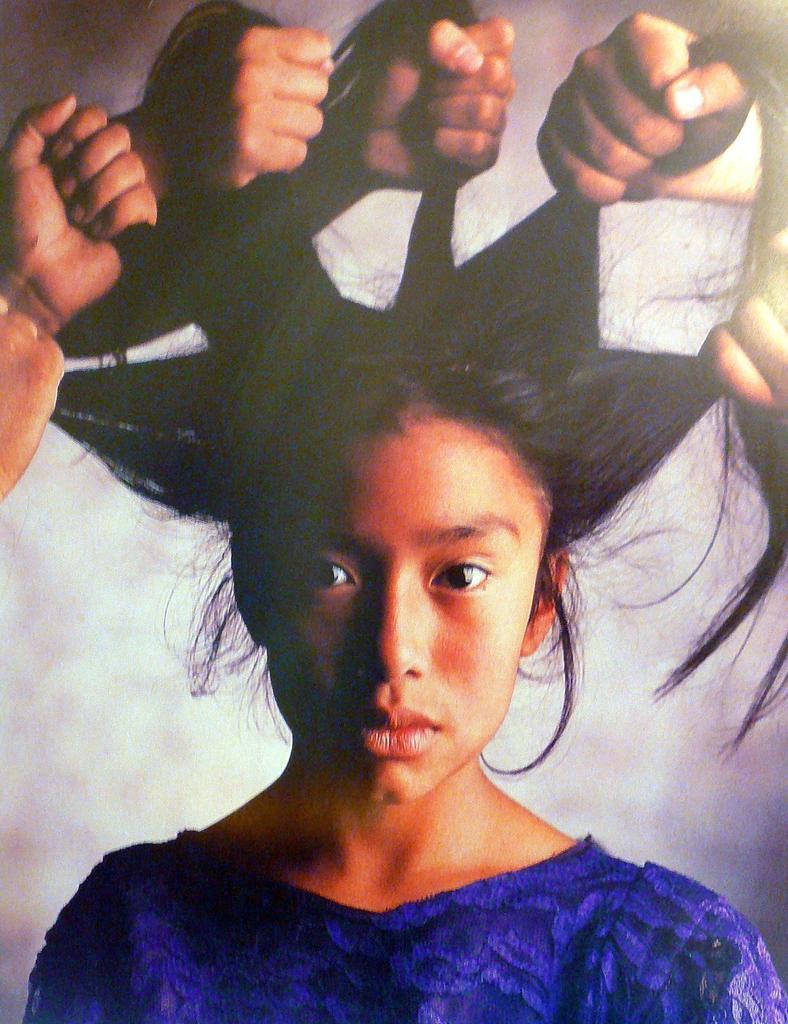Can you describe this image briefly? In this image, we can see a woman, we can see the hands of the people holding the hairs of a woman. 